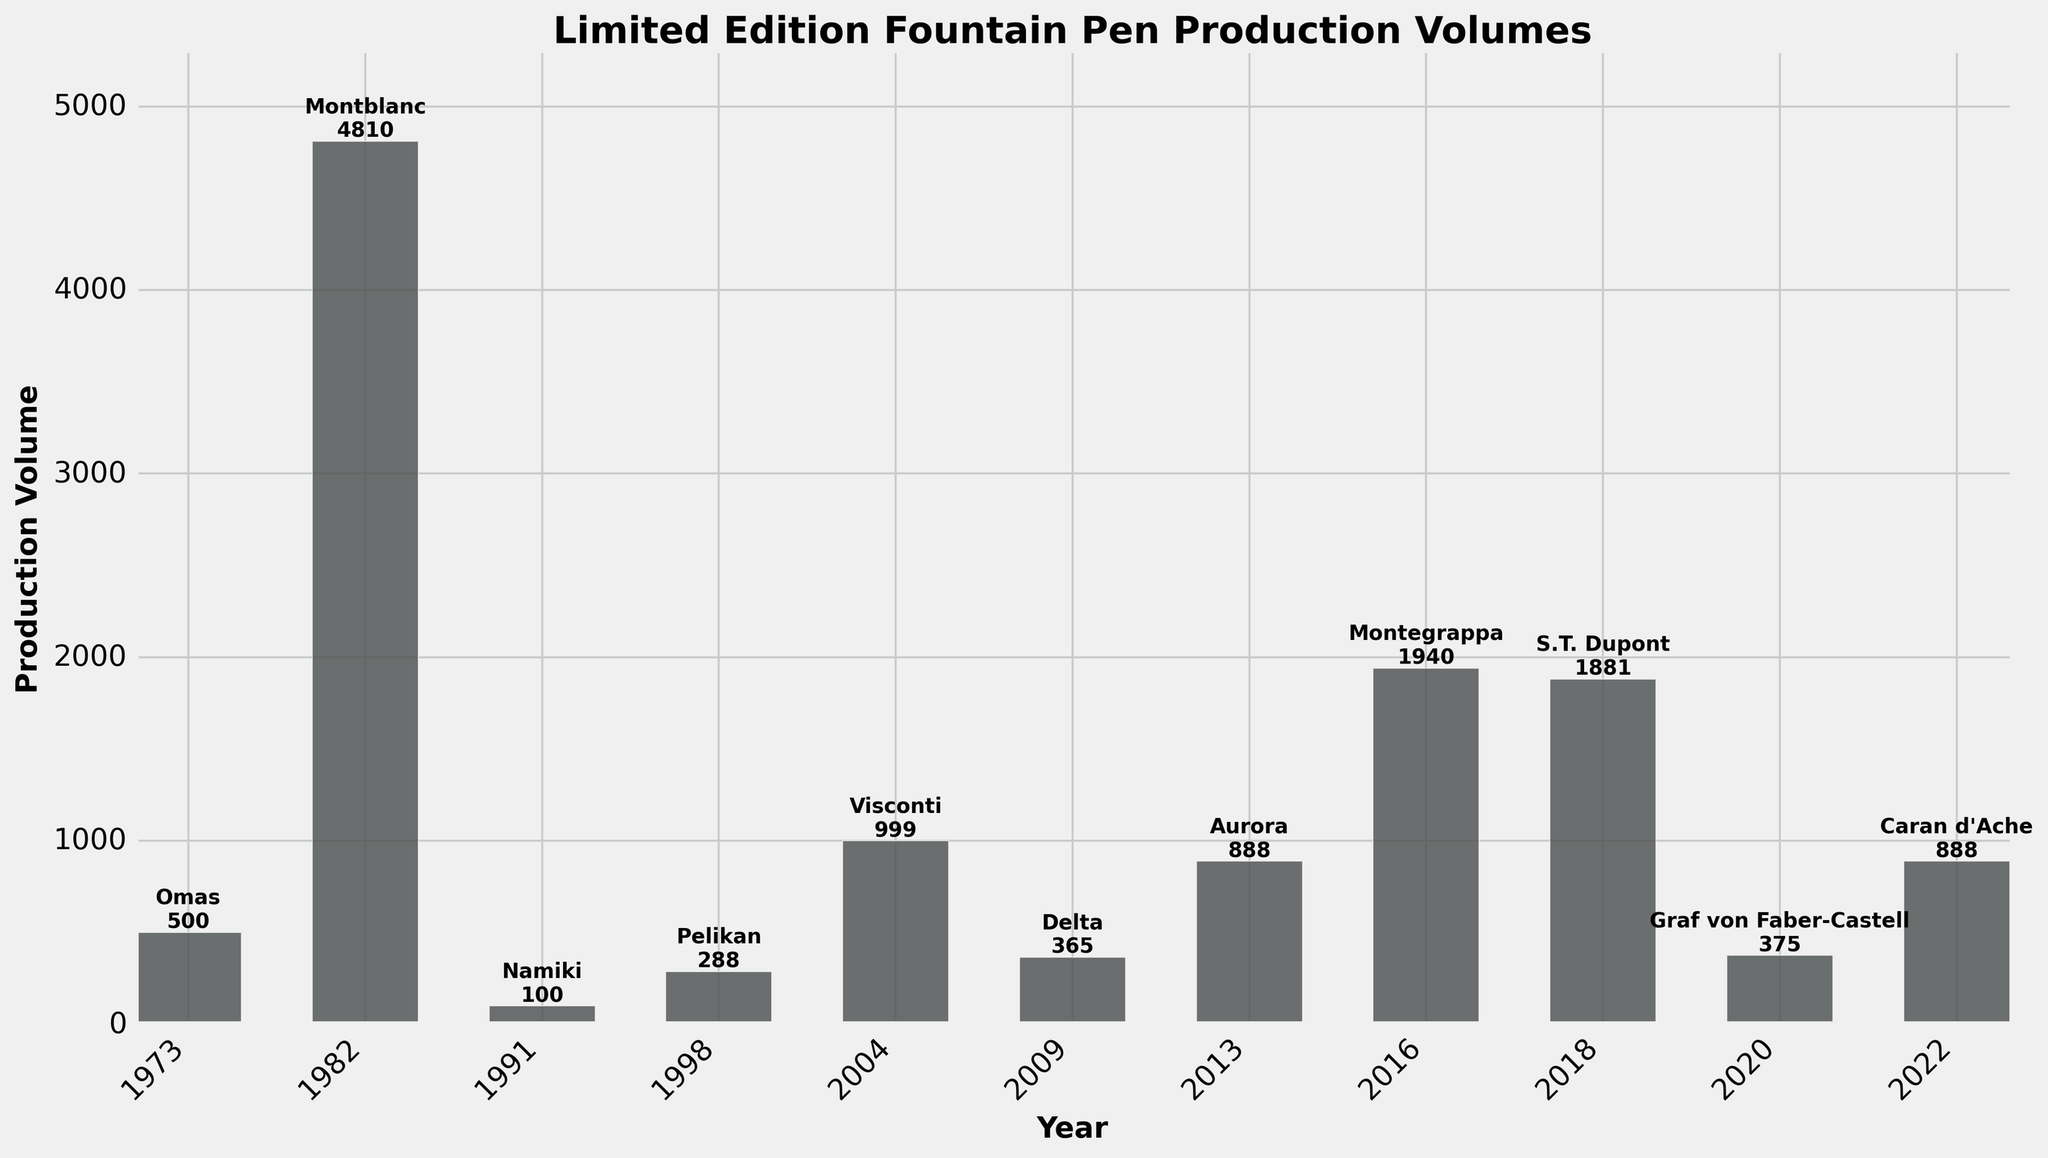What's the average production volume for the pens produced after 2000? To find the average, sum the volumes of pens produced after 2000 and divide by the number of those pens. The volumes are 999 (2004), 365 (2009), 888 (2013), 1940 (2016), 1881 (2018), 375 (2020), and 888 (2022). So, `(999 + 365 + 888 + 1940 + 1881 + 375 + 888) / 7 = 8336 / 7 ≈ 1191.43`.
Answer: 1191.43 Which year had the highest production volume and what was it? Look for the tallest bar in the chart. The year with the highest production volume is 1982 with a volume of 4810.
Answer: 1982, 4810 Compare the production volumes of the Montegrappa Pelé Limited Edition and the Aurora 88 Sole Limited Edition. Which one is higher and by how much? Montegrappa's Pelé Limited Edition (2016) has a volume of 1940; Aurora's 88 Sole Limited Edition (2013) has 888. The difference is `1940 - 888 = 1052`. Montegrappa's volume is higher by 1052.
Answer: Montegrappa, 1052 What is the total production volume for pens produced in the 1990s? Sum the production volumes of pens from 1991 and 1998. The volumes are 100 (1991) and 288 (1998). The total is `100 + 288 = 388`.
Answer: 388 Which craftsman has the most recent production, and how many pens were produced in that year? The most recent production year is 2022 by Caran d'Ache. The production volume is 888.
Answer: Caran d'Ache, 888 How many craftsmen have produced pens with a volume greater than 1000? Identify all craftsmen with production volumes above 1000. These are Montblanc (4810), Montegrappa (1940), and S.T. Dupont (1881). Therefore, there are 3 craftsmen.
Answer: 3 Plot the overall trend of production volumes over the years. Are there any noticeable patterns? By observing the bar heights across the years from 1973 to 2022, it can be seen that volumes are generally increasing with specific peaks in 1982, 2016, and 2018. The bars' variations suggest occasional high-volume productions amid lower volumes.
Answer: Increasing trend with occasional peaks What’s the difference in production volume between the highest and the lowest produced pens? The highest production volume is 4810 (1982 Montblanc), and the lowest is 100 (1991 Namiki). The difference is `4810 - 100 = 4710`.
Answer: 4710 Which pen model has the closest production volume to 1000, and what is that volume? Check the closest value to 1000. Visconti's Divina Proporzione HRH (2004) has 999, which is closest to 1000.
Answer: Visconti Divina Proporzione HRH, 999 What is the median production volume of all the pens listed? Arrange volumes in ascending order: 100, 288, 365, 375, 500, 888, 888, 1881, 1940, 4810. The median value, being the average of 5th and 6th in this ordered list, is `(500 + 888) / 2 = 694`.
Answer: 694 